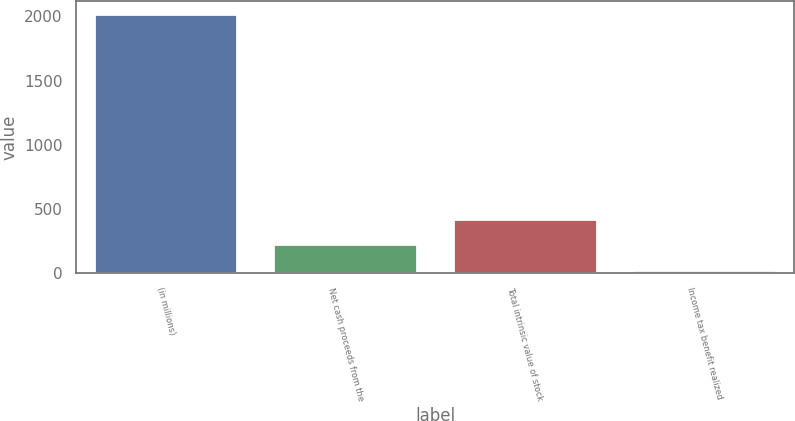Convert chart to OTSL. <chart><loc_0><loc_0><loc_500><loc_500><bar_chart><fcel>(in millions)<fcel>Net cash proceeds from the<fcel>Total intrinsic value of stock<fcel>Income tax benefit realized<nl><fcel>2018<fcel>226.1<fcel>425.2<fcel>27<nl></chart> 